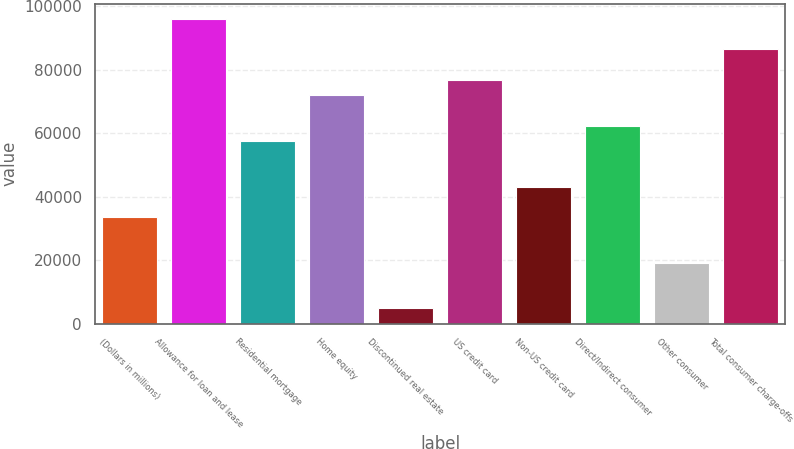Convert chart. <chart><loc_0><loc_0><loc_500><loc_500><bar_chart><fcel>(Dollars in millions)<fcel>Allowance for loan and lease<fcel>Residential mortgage<fcel>Home equity<fcel>Discontinued real estate<fcel>US credit card<fcel>Non-US credit card<fcel>Direct/Indirect consumer<fcel>Other consumer<fcel>Total consumer charge-offs<nl><fcel>33602.4<fcel>95940<fcel>57578.4<fcel>71964<fcel>4831.2<fcel>76759.2<fcel>43192.8<fcel>62373.6<fcel>19216.8<fcel>86349.6<nl></chart> 